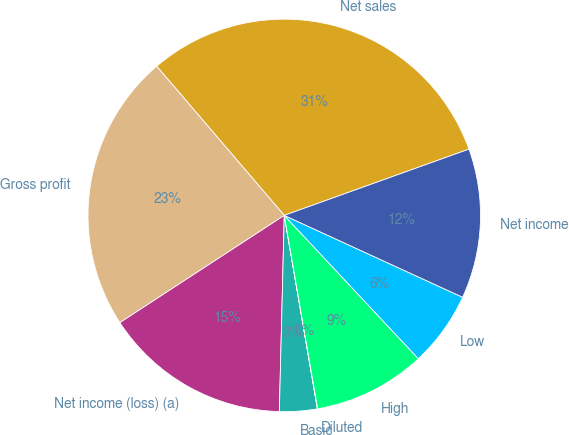Convert chart. <chart><loc_0><loc_0><loc_500><loc_500><pie_chart><fcel>Net sales<fcel>Gross profit<fcel>Net income (loss) (a)<fcel>Basic<fcel>Diluted<fcel>High<fcel>Low<fcel>Net income<nl><fcel>30.78%<fcel>22.94%<fcel>15.4%<fcel>3.1%<fcel>0.02%<fcel>9.25%<fcel>6.18%<fcel>12.33%<nl></chart> 